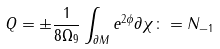Convert formula to latex. <formula><loc_0><loc_0><loc_500><loc_500>Q = \pm \frac { 1 } { 8 \Omega _ { 9 } } \int _ { \partial M } e ^ { 2 \phi } \partial \chi \colon = N _ { - 1 }</formula> 